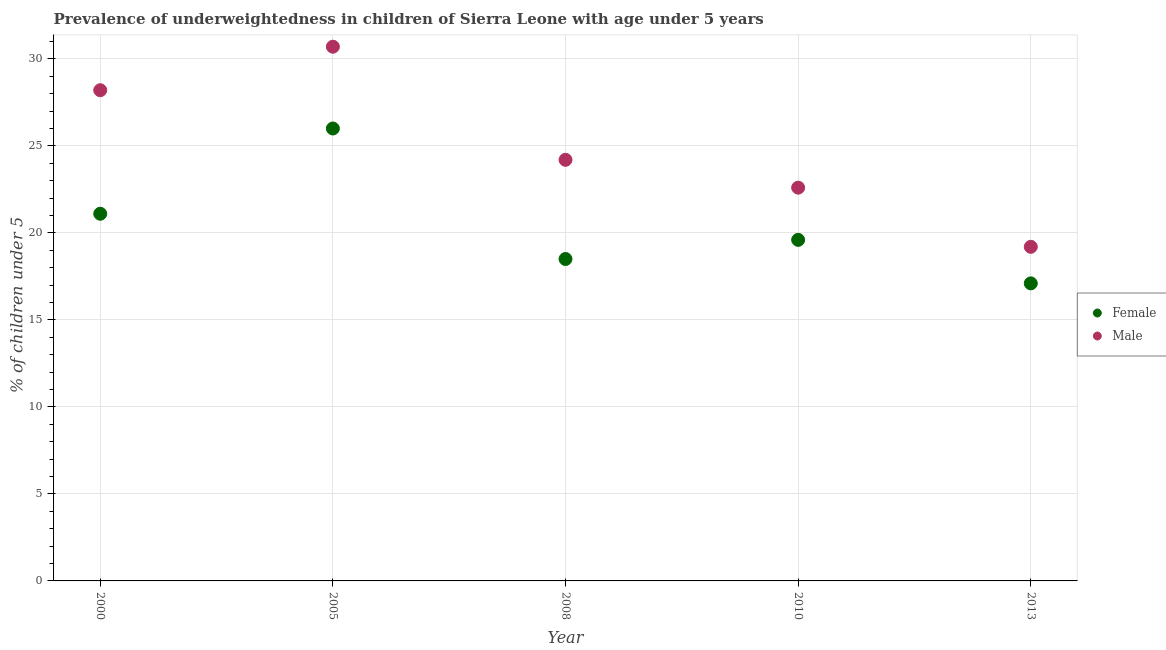How many different coloured dotlines are there?
Give a very brief answer. 2. Is the number of dotlines equal to the number of legend labels?
Keep it short and to the point. Yes. What is the percentage of underweighted male children in 2008?
Your answer should be compact. 24.2. Across all years, what is the maximum percentage of underweighted male children?
Make the answer very short. 30.7. Across all years, what is the minimum percentage of underweighted female children?
Your answer should be compact. 17.1. In which year was the percentage of underweighted female children minimum?
Provide a succinct answer. 2013. What is the total percentage of underweighted female children in the graph?
Offer a very short reply. 102.3. What is the difference between the percentage of underweighted female children in 2010 and the percentage of underweighted male children in 2008?
Give a very brief answer. -4.6. What is the average percentage of underweighted male children per year?
Offer a terse response. 24.98. In the year 2000, what is the difference between the percentage of underweighted female children and percentage of underweighted male children?
Give a very brief answer. -7.1. In how many years, is the percentage of underweighted male children greater than 2 %?
Offer a terse response. 5. What is the ratio of the percentage of underweighted male children in 2008 to that in 2010?
Provide a succinct answer. 1.07. Is the percentage of underweighted male children in 2008 less than that in 2013?
Make the answer very short. No. Is the difference between the percentage of underweighted female children in 2000 and 2013 greater than the difference between the percentage of underweighted male children in 2000 and 2013?
Offer a very short reply. No. What is the difference between the highest and the second highest percentage of underweighted male children?
Your answer should be very brief. 2.5. What is the difference between the highest and the lowest percentage of underweighted female children?
Make the answer very short. 8.9. In how many years, is the percentage of underweighted female children greater than the average percentage of underweighted female children taken over all years?
Offer a very short reply. 2. Is the sum of the percentage of underweighted female children in 2008 and 2013 greater than the maximum percentage of underweighted male children across all years?
Your response must be concise. Yes. Does the percentage of underweighted female children monotonically increase over the years?
Make the answer very short. No. Is the percentage of underweighted male children strictly greater than the percentage of underweighted female children over the years?
Your response must be concise. Yes. Is the percentage of underweighted female children strictly less than the percentage of underweighted male children over the years?
Give a very brief answer. Yes. How many dotlines are there?
Give a very brief answer. 2. Does the graph contain grids?
Your answer should be compact. Yes. How many legend labels are there?
Provide a short and direct response. 2. How are the legend labels stacked?
Your response must be concise. Vertical. What is the title of the graph?
Your answer should be compact. Prevalence of underweightedness in children of Sierra Leone with age under 5 years. Does "Methane emissions" appear as one of the legend labels in the graph?
Offer a terse response. No. What is the label or title of the X-axis?
Ensure brevity in your answer.  Year. What is the label or title of the Y-axis?
Provide a short and direct response.  % of children under 5. What is the  % of children under 5 of Female in 2000?
Provide a succinct answer. 21.1. What is the  % of children under 5 of Male in 2000?
Give a very brief answer. 28.2. What is the  % of children under 5 of Male in 2005?
Offer a terse response. 30.7. What is the  % of children under 5 in Male in 2008?
Make the answer very short. 24.2. What is the  % of children under 5 in Female in 2010?
Offer a terse response. 19.6. What is the  % of children under 5 in Male in 2010?
Your answer should be very brief. 22.6. What is the  % of children under 5 in Female in 2013?
Give a very brief answer. 17.1. What is the  % of children under 5 of Male in 2013?
Your answer should be very brief. 19.2. Across all years, what is the maximum  % of children under 5 of Female?
Your answer should be very brief. 26. Across all years, what is the maximum  % of children under 5 of Male?
Ensure brevity in your answer.  30.7. Across all years, what is the minimum  % of children under 5 of Female?
Offer a very short reply. 17.1. Across all years, what is the minimum  % of children under 5 in Male?
Make the answer very short. 19.2. What is the total  % of children under 5 in Female in the graph?
Your response must be concise. 102.3. What is the total  % of children under 5 of Male in the graph?
Provide a succinct answer. 124.9. What is the difference between the  % of children under 5 in Male in 2000 and that in 2008?
Offer a very short reply. 4. What is the difference between the  % of children under 5 in Female in 2000 and that in 2010?
Give a very brief answer. 1.5. What is the difference between the  % of children under 5 in Male in 2000 and that in 2013?
Make the answer very short. 9. What is the difference between the  % of children under 5 in Female in 2005 and that in 2008?
Offer a very short reply. 7.5. What is the difference between the  % of children under 5 of Male in 2005 and that in 2008?
Your response must be concise. 6.5. What is the difference between the  % of children under 5 in Female in 2005 and that in 2010?
Your answer should be very brief. 6.4. What is the difference between the  % of children under 5 in Female in 2005 and that in 2013?
Provide a succinct answer. 8.9. What is the difference between the  % of children under 5 in Male in 2005 and that in 2013?
Offer a terse response. 11.5. What is the difference between the  % of children under 5 in Female in 2008 and that in 2010?
Keep it short and to the point. -1.1. What is the difference between the  % of children under 5 in Female in 2010 and that in 2013?
Your response must be concise. 2.5. What is the difference between the  % of children under 5 of Male in 2010 and that in 2013?
Your response must be concise. 3.4. What is the difference between the  % of children under 5 of Female in 2000 and the  % of children under 5 of Male in 2005?
Ensure brevity in your answer.  -9.6. What is the difference between the  % of children under 5 of Female in 2000 and the  % of children under 5 of Male in 2010?
Give a very brief answer. -1.5. What is the difference between the  % of children under 5 in Female in 2000 and the  % of children under 5 in Male in 2013?
Keep it short and to the point. 1.9. What is the difference between the  % of children under 5 in Female in 2005 and the  % of children under 5 in Male in 2008?
Provide a short and direct response. 1.8. What is the difference between the  % of children under 5 in Female in 2008 and the  % of children under 5 in Male in 2010?
Ensure brevity in your answer.  -4.1. What is the average  % of children under 5 in Female per year?
Your answer should be very brief. 20.46. What is the average  % of children under 5 of Male per year?
Ensure brevity in your answer.  24.98. In the year 2000, what is the difference between the  % of children under 5 in Female and  % of children under 5 in Male?
Offer a very short reply. -7.1. In the year 2005, what is the difference between the  % of children under 5 in Female and  % of children under 5 in Male?
Provide a short and direct response. -4.7. In the year 2010, what is the difference between the  % of children under 5 in Female and  % of children under 5 in Male?
Give a very brief answer. -3. In the year 2013, what is the difference between the  % of children under 5 in Female and  % of children under 5 in Male?
Your answer should be very brief. -2.1. What is the ratio of the  % of children under 5 of Female in 2000 to that in 2005?
Your answer should be compact. 0.81. What is the ratio of the  % of children under 5 in Male in 2000 to that in 2005?
Offer a terse response. 0.92. What is the ratio of the  % of children under 5 in Female in 2000 to that in 2008?
Give a very brief answer. 1.14. What is the ratio of the  % of children under 5 of Male in 2000 to that in 2008?
Provide a succinct answer. 1.17. What is the ratio of the  % of children under 5 in Female in 2000 to that in 2010?
Your answer should be compact. 1.08. What is the ratio of the  % of children under 5 in Male in 2000 to that in 2010?
Ensure brevity in your answer.  1.25. What is the ratio of the  % of children under 5 of Female in 2000 to that in 2013?
Keep it short and to the point. 1.23. What is the ratio of the  % of children under 5 of Male in 2000 to that in 2013?
Your response must be concise. 1.47. What is the ratio of the  % of children under 5 in Female in 2005 to that in 2008?
Offer a very short reply. 1.41. What is the ratio of the  % of children under 5 in Male in 2005 to that in 2008?
Provide a succinct answer. 1.27. What is the ratio of the  % of children under 5 in Female in 2005 to that in 2010?
Offer a terse response. 1.33. What is the ratio of the  % of children under 5 in Male in 2005 to that in 2010?
Provide a short and direct response. 1.36. What is the ratio of the  % of children under 5 of Female in 2005 to that in 2013?
Provide a succinct answer. 1.52. What is the ratio of the  % of children under 5 in Male in 2005 to that in 2013?
Offer a terse response. 1.6. What is the ratio of the  % of children under 5 of Female in 2008 to that in 2010?
Offer a very short reply. 0.94. What is the ratio of the  % of children under 5 of Male in 2008 to that in 2010?
Offer a very short reply. 1.07. What is the ratio of the  % of children under 5 of Female in 2008 to that in 2013?
Give a very brief answer. 1.08. What is the ratio of the  % of children under 5 of Male in 2008 to that in 2013?
Your answer should be very brief. 1.26. What is the ratio of the  % of children under 5 in Female in 2010 to that in 2013?
Ensure brevity in your answer.  1.15. What is the ratio of the  % of children under 5 of Male in 2010 to that in 2013?
Ensure brevity in your answer.  1.18. What is the difference between the highest and the second highest  % of children under 5 in Male?
Ensure brevity in your answer.  2.5. What is the difference between the highest and the lowest  % of children under 5 of Male?
Provide a short and direct response. 11.5. 